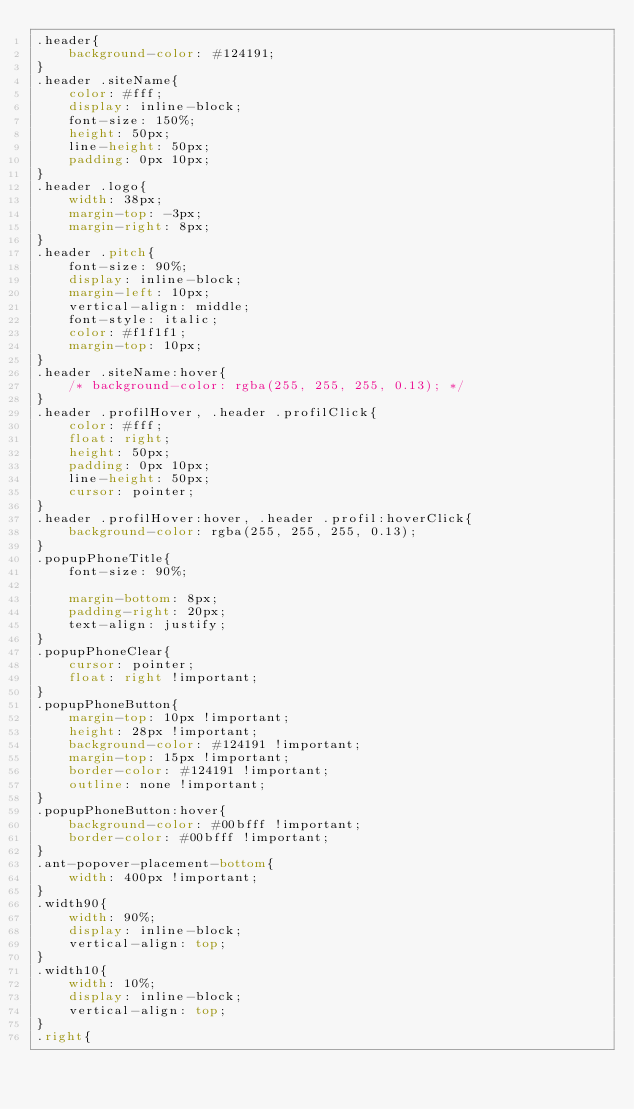<code> <loc_0><loc_0><loc_500><loc_500><_CSS_>.header{
    background-color: #124191;
}
.header .siteName{
    color: #fff;
    display: inline-block;
    font-size: 150%;
    height: 50px;
    line-height: 50px;
    padding: 0px 10px;
}
.header .logo{
    width: 38px;
    margin-top: -3px;
    margin-right: 8px;
}
.header .pitch{
    font-size: 90%;
    display: inline-block;
    margin-left: 10px;
    vertical-align: middle;
    font-style: italic;
    color: #f1f1f1;
    margin-top: 10px;
}
.header .siteName:hover{
    /* background-color: rgba(255, 255, 255, 0.13); */
}
.header .profilHover, .header .profilClick{
    color: #fff;
    float: right;
    height: 50px;
    padding: 0px 10px;
    line-height: 50px;
    cursor: pointer;
}
.header .profilHover:hover, .header .profil:hoverClick{
    background-color: rgba(255, 255, 255, 0.13);
}
.popupPhoneTitle{
    font-size: 90%;

    margin-bottom: 8px;
    padding-right: 20px;
    text-align: justify;
}
.popupPhoneClear{
    cursor: pointer;
    float: right !important;
}
.popupPhoneButton{
    margin-top: 10px !important;
    height: 28px !important;
    background-color: #124191 !important;
    margin-top: 15px !important;
    border-color: #124191 !important;
    outline: none !important;
}
.popupPhoneButton:hover{
    background-color: #00bfff !important;
    border-color: #00bfff !important;
}
.ant-popover-placement-bottom{
    width: 400px !important;
}
.width90{
    width: 90%;
    display: inline-block;
    vertical-align: top;
}
.width10{
    width: 10%;
    display: inline-block;
    vertical-align: top;
}
.right{</code> 